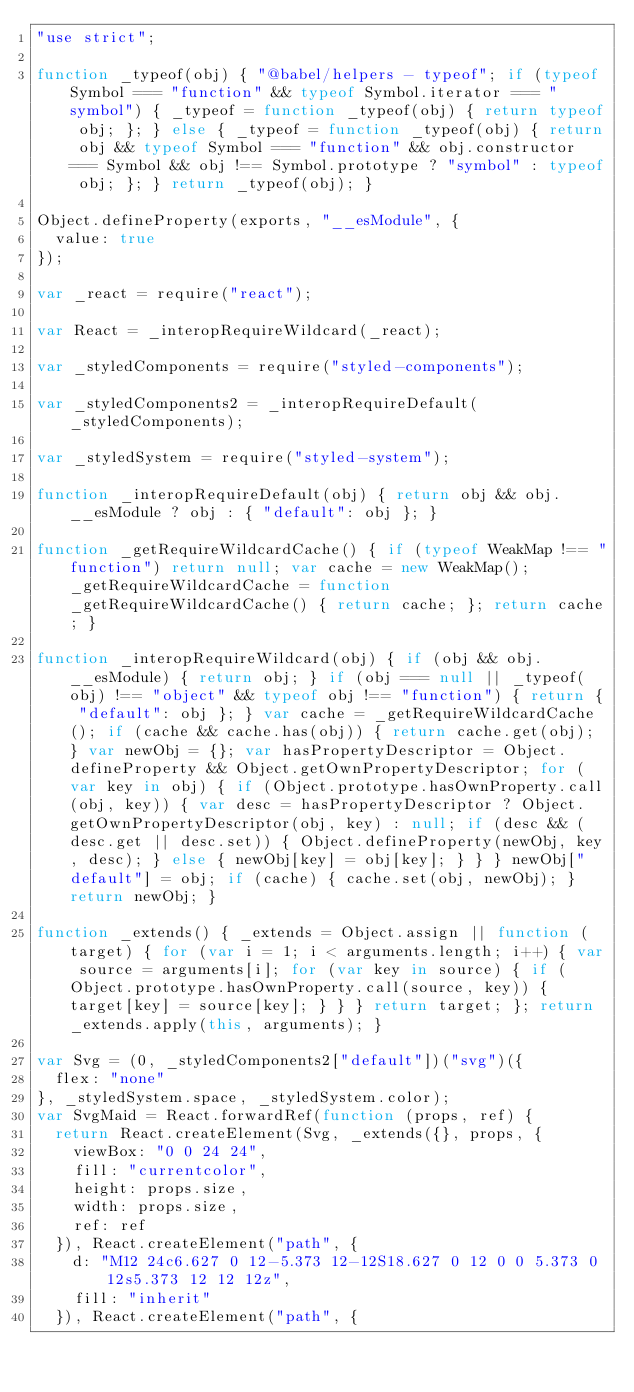Convert code to text. <code><loc_0><loc_0><loc_500><loc_500><_JavaScript_>"use strict";

function _typeof(obj) { "@babel/helpers - typeof"; if (typeof Symbol === "function" && typeof Symbol.iterator === "symbol") { _typeof = function _typeof(obj) { return typeof obj; }; } else { _typeof = function _typeof(obj) { return obj && typeof Symbol === "function" && obj.constructor === Symbol && obj !== Symbol.prototype ? "symbol" : typeof obj; }; } return _typeof(obj); }

Object.defineProperty(exports, "__esModule", {
  value: true
});

var _react = require("react");

var React = _interopRequireWildcard(_react);

var _styledComponents = require("styled-components");

var _styledComponents2 = _interopRequireDefault(_styledComponents);

var _styledSystem = require("styled-system");

function _interopRequireDefault(obj) { return obj && obj.__esModule ? obj : { "default": obj }; }

function _getRequireWildcardCache() { if (typeof WeakMap !== "function") return null; var cache = new WeakMap(); _getRequireWildcardCache = function _getRequireWildcardCache() { return cache; }; return cache; }

function _interopRequireWildcard(obj) { if (obj && obj.__esModule) { return obj; } if (obj === null || _typeof(obj) !== "object" && typeof obj !== "function") { return { "default": obj }; } var cache = _getRequireWildcardCache(); if (cache && cache.has(obj)) { return cache.get(obj); } var newObj = {}; var hasPropertyDescriptor = Object.defineProperty && Object.getOwnPropertyDescriptor; for (var key in obj) { if (Object.prototype.hasOwnProperty.call(obj, key)) { var desc = hasPropertyDescriptor ? Object.getOwnPropertyDescriptor(obj, key) : null; if (desc && (desc.get || desc.set)) { Object.defineProperty(newObj, key, desc); } else { newObj[key] = obj[key]; } } } newObj["default"] = obj; if (cache) { cache.set(obj, newObj); } return newObj; }

function _extends() { _extends = Object.assign || function (target) { for (var i = 1; i < arguments.length; i++) { var source = arguments[i]; for (var key in source) { if (Object.prototype.hasOwnProperty.call(source, key)) { target[key] = source[key]; } } } return target; }; return _extends.apply(this, arguments); }

var Svg = (0, _styledComponents2["default"])("svg")({
  flex: "none"
}, _styledSystem.space, _styledSystem.color);
var SvgMaid = React.forwardRef(function (props, ref) {
  return React.createElement(Svg, _extends({}, props, {
    viewBox: "0 0 24 24",
    fill: "currentcolor",
    height: props.size,
    width: props.size,
    ref: ref
  }), React.createElement("path", {
    d: "M12 24c6.627 0 12-5.373 12-12S18.627 0 12 0 0 5.373 0 12s5.373 12 12 12z",
    fill: "inherit"
  }), React.createElement("path", {</code> 